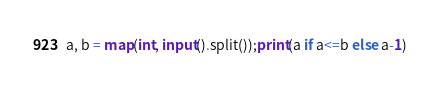Convert code to text. <code><loc_0><loc_0><loc_500><loc_500><_Python_>a, b = map(int, input().split());print(a if a<=b else a-1)</code> 